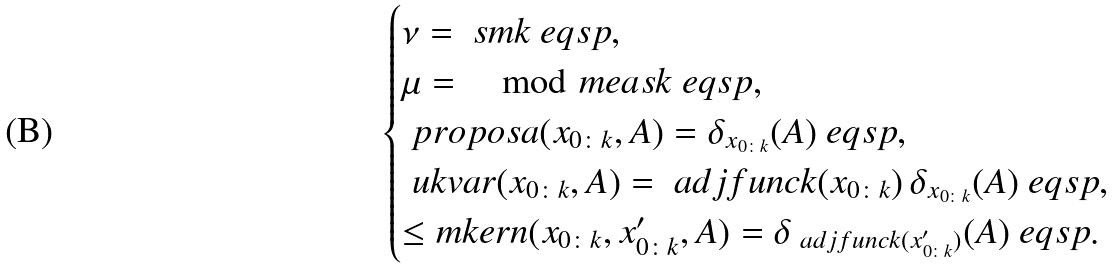<formula> <loc_0><loc_0><loc_500><loc_500>\begin{cases} \nu = \ s m { k } \ e q s p , \\ \mu = \mod m e a s { k } \ e q s p , \\ \ p r o p o s a ( x _ { 0 \colon k } , A ) = \delta _ { x _ { 0 \colon k } } ( A ) \ e q s p , \\ \ u k v a r ( x _ { 0 \colon k } , A ) = \ a d j f u n c { k } ( x _ { 0 \colon k } ) \, \delta _ { x _ { 0 \colon k } } ( A ) \ e q s p , \\ \leq m k e r n ( x _ { 0 \colon k } , x _ { 0 \colon k } ^ { \prime } , A ) = \delta _ { \ a d j f u n c { k } ( x _ { 0 \colon k } ^ { \prime } ) } ( A ) \ e q s p . \end{cases}</formula> 